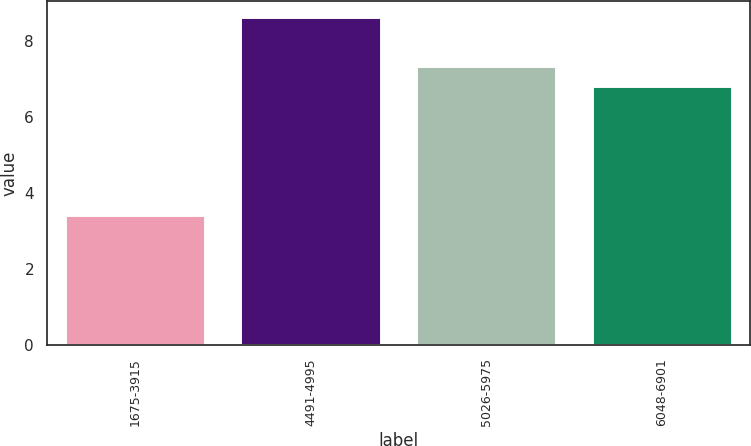Convert chart. <chart><loc_0><loc_0><loc_500><loc_500><bar_chart><fcel>1675-3915<fcel>4491-4995<fcel>5026-5975<fcel>6048-6901<nl><fcel>3.41<fcel>8.62<fcel>7.33<fcel>6.81<nl></chart> 